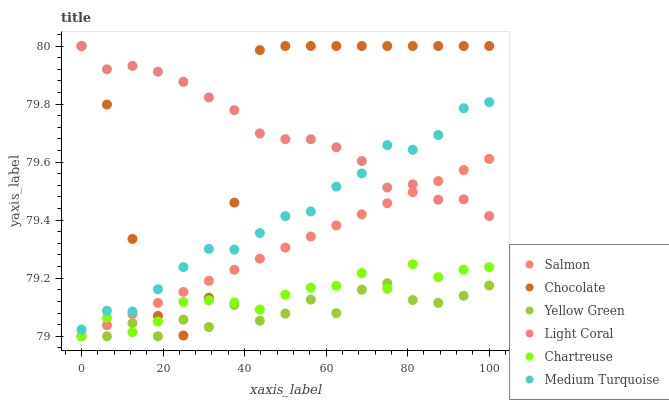Does Yellow Green have the minimum area under the curve?
Answer yes or no. Yes. Does Chocolate have the maximum area under the curve?
Answer yes or no. Yes. Does Salmon have the minimum area under the curve?
Answer yes or no. No. Does Salmon have the maximum area under the curve?
Answer yes or no. No. Is Salmon the smoothest?
Answer yes or no. Yes. Is Chocolate the roughest?
Answer yes or no. Yes. Is Chocolate the smoothest?
Answer yes or no. No. Is Salmon the roughest?
Answer yes or no. No. Does Yellow Green have the lowest value?
Answer yes or no. Yes. Does Chocolate have the lowest value?
Answer yes or no. No. Does Light Coral have the highest value?
Answer yes or no. Yes. Does Salmon have the highest value?
Answer yes or no. No. Is Chartreuse less than Light Coral?
Answer yes or no. Yes. Is Medium Turquoise greater than Salmon?
Answer yes or no. Yes. Does Medium Turquoise intersect Chocolate?
Answer yes or no. Yes. Is Medium Turquoise less than Chocolate?
Answer yes or no. No. Is Medium Turquoise greater than Chocolate?
Answer yes or no. No. Does Chartreuse intersect Light Coral?
Answer yes or no. No. 